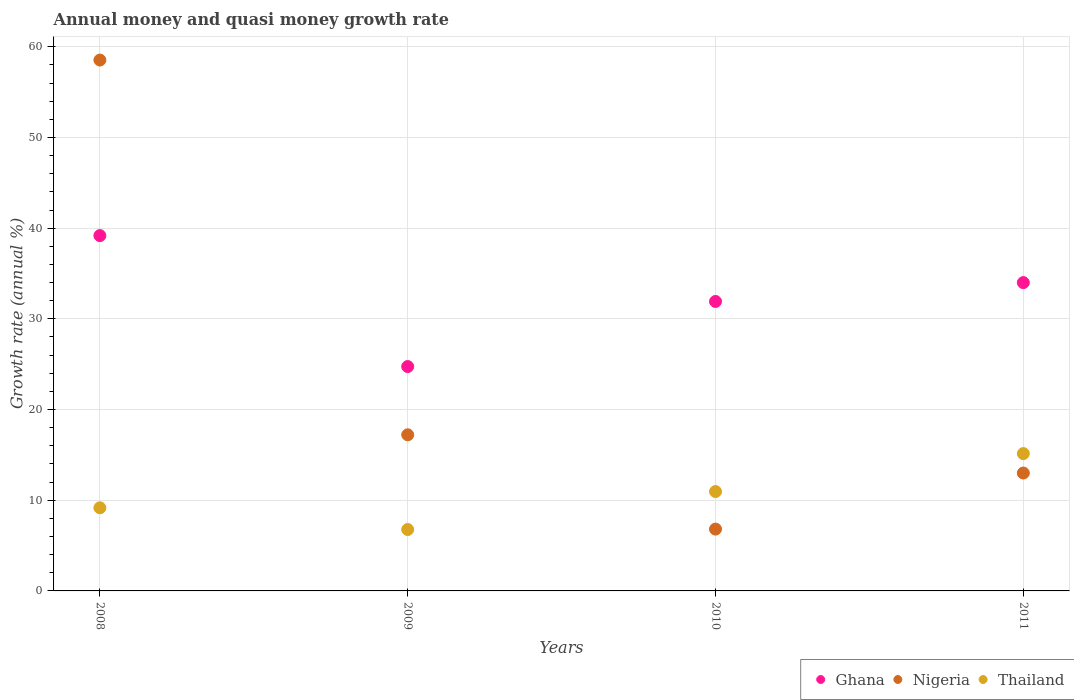How many different coloured dotlines are there?
Your answer should be compact. 3. Is the number of dotlines equal to the number of legend labels?
Keep it short and to the point. Yes. What is the growth rate in Ghana in 2008?
Make the answer very short. 39.18. Across all years, what is the maximum growth rate in Thailand?
Ensure brevity in your answer.  15.14. Across all years, what is the minimum growth rate in Nigeria?
Provide a succinct answer. 6.82. In which year was the growth rate in Thailand maximum?
Offer a very short reply. 2011. What is the total growth rate in Nigeria in the graph?
Make the answer very short. 95.56. What is the difference between the growth rate in Nigeria in 2008 and that in 2010?
Your answer should be compact. 51.72. What is the difference between the growth rate in Nigeria in 2009 and the growth rate in Ghana in 2010?
Offer a very short reply. -14.7. What is the average growth rate in Thailand per year?
Keep it short and to the point. 10.51. In the year 2009, what is the difference between the growth rate in Nigeria and growth rate in Thailand?
Your answer should be compact. 10.44. In how many years, is the growth rate in Thailand greater than 4 %?
Offer a very short reply. 4. What is the ratio of the growth rate in Ghana in 2009 to that in 2010?
Offer a very short reply. 0.78. Is the growth rate in Nigeria in 2009 less than that in 2011?
Ensure brevity in your answer.  No. Is the difference between the growth rate in Nigeria in 2008 and 2011 greater than the difference between the growth rate in Thailand in 2008 and 2011?
Keep it short and to the point. Yes. What is the difference between the highest and the second highest growth rate in Nigeria?
Your answer should be compact. 41.32. What is the difference between the highest and the lowest growth rate in Thailand?
Offer a terse response. 8.37. Is it the case that in every year, the sum of the growth rate in Ghana and growth rate in Thailand  is greater than the growth rate in Nigeria?
Offer a terse response. No. Does the growth rate in Ghana monotonically increase over the years?
Keep it short and to the point. No. What is the difference between two consecutive major ticks on the Y-axis?
Provide a succinct answer. 10. Are the values on the major ticks of Y-axis written in scientific E-notation?
Ensure brevity in your answer.  No. Does the graph contain any zero values?
Make the answer very short. No. Does the graph contain grids?
Provide a succinct answer. Yes. How many legend labels are there?
Your response must be concise. 3. How are the legend labels stacked?
Your response must be concise. Horizontal. What is the title of the graph?
Keep it short and to the point. Annual money and quasi money growth rate. What is the label or title of the Y-axis?
Your answer should be very brief. Growth rate (annual %). What is the Growth rate (annual %) of Ghana in 2008?
Keep it short and to the point. 39.18. What is the Growth rate (annual %) of Nigeria in 2008?
Ensure brevity in your answer.  58.53. What is the Growth rate (annual %) in Thailand in 2008?
Offer a terse response. 9.17. What is the Growth rate (annual %) in Ghana in 2009?
Provide a succinct answer. 24.74. What is the Growth rate (annual %) of Nigeria in 2009?
Offer a very short reply. 17.21. What is the Growth rate (annual %) in Thailand in 2009?
Your answer should be compact. 6.77. What is the Growth rate (annual %) in Ghana in 2010?
Make the answer very short. 31.92. What is the Growth rate (annual %) of Nigeria in 2010?
Offer a terse response. 6.82. What is the Growth rate (annual %) in Thailand in 2010?
Provide a short and direct response. 10.96. What is the Growth rate (annual %) in Ghana in 2011?
Ensure brevity in your answer.  33.99. What is the Growth rate (annual %) of Nigeria in 2011?
Your response must be concise. 13. What is the Growth rate (annual %) of Thailand in 2011?
Your response must be concise. 15.14. Across all years, what is the maximum Growth rate (annual %) of Ghana?
Your response must be concise. 39.18. Across all years, what is the maximum Growth rate (annual %) in Nigeria?
Make the answer very short. 58.53. Across all years, what is the maximum Growth rate (annual %) in Thailand?
Make the answer very short. 15.14. Across all years, what is the minimum Growth rate (annual %) of Ghana?
Your answer should be very brief. 24.74. Across all years, what is the minimum Growth rate (annual %) in Nigeria?
Ensure brevity in your answer.  6.82. Across all years, what is the minimum Growth rate (annual %) of Thailand?
Keep it short and to the point. 6.77. What is the total Growth rate (annual %) of Ghana in the graph?
Ensure brevity in your answer.  129.83. What is the total Growth rate (annual %) of Nigeria in the graph?
Your answer should be compact. 95.56. What is the total Growth rate (annual %) in Thailand in the graph?
Provide a succinct answer. 42.04. What is the difference between the Growth rate (annual %) in Ghana in 2008 and that in 2009?
Your answer should be compact. 14.44. What is the difference between the Growth rate (annual %) of Nigeria in 2008 and that in 2009?
Your answer should be compact. 41.32. What is the difference between the Growth rate (annual %) of Thailand in 2008 and that in 2009?
Provide a succinct answer. 2.4. What is the difference between the Growth rate (annual %) in Ghana in 2008 and that in 2010?
Your answer should be compact. 7.26. What is the difference between the Growth rate (annual %) of Nigeria in 2008 and that in 2010?
Your response must be concise. 51.72. What is the difference between the Growth rate (annual %) of Thailand in 2008 and that in 2010?
Offer a very short reply. -1.79. What is the difference between the Growth rate (annual %) of Ghana in 2008 and that in 2011?
Offer a terse response. 5.18. What is the difference between the Growth rate (annual %) of Nigeria in 2008 and that in 2011?
Your answer should be very brief. 45.54. What is the difference between the Growth rate (annual %) of Thailand in 2008 and that in 2011?
Give a very brief answer. -5.98. What is the difference between the Growth rate (annual %) of Ghana in 2009 and that in 2010?
Give a very brief answer. -7.18. What is the difference between the Growth rate (annual %) of Nigeria in 2009 and that in 2010?
Offer a terse response. 10.4. What is the difference between the Growth rate (annual %) in Thailand in 2009 and that in 2010?
Make the answer very short. -4.19. What is the difference between the Growth rate (annual %) in Ghana in 2009 and that in 2011?
Your response must be concise. -9.26. What is the difference between the Growth rate (annual %) of Nigeria in 2009 and that in 2011?
Give a very brief answer. 4.22. What is the difference between the Growth rate (annual %) in Thailand in 2009 and that in 2011?
Keep it short and to the point. -8.37. What is the difference between the Growth rate (annual %) in Ghana in 2010 and that in 2011?
Offer a very short reply. -2.08. What is the difference between the Growth rate (annual %) in Nigeria in 2010 and that in 2011?
Keep it short and to the point. -6.18. What is the difference between the Growth rate (annual %) in Thailand in 2010 and that in 2011?
Give a very brief answer. -4.18. What is the difference between the Growth rate (annual %) of Ghana in 2008 and the Growth rate (annual %) of Nigeria in 2009?
Your response must be concise. 21.96. What is the difference between the Growth rate (annual %) in Ghana in 2008 and the Growth rate (annual %) in Thailand in 2009?
Offer a terse response. 32.41. What is the difference between the Growth rate (annual %) of Nigeria in 2008 and the Growth rate (annual %) of Thailand in 2009?
Offer a terse response. 51.76. What is the difference between the Growth rate (annual %) in Ghana in 2008 and the Growth rate (annual %) in Nigeria in 2010?
Keep it short and to the point. 32.36. What is the difference between the Growth rate (annual %) of Ghana in 2008 and the Growth rate (annual %) of Thailand in 2010?
Ensure brevity in your answer.  28.22. What is the difference between the Growth rate (annual %) of Nigeria in 2008 and the Growth rate (annual %) of Thailand in 2010?
Make the answer very short. 47.58. What is the difference between the Growth rate (annual %) of Ghana in 2008 and the Growth rate (annual %) of Nigeria in 2011?
Offer a terse response. 26.18. What is the difference between the Growth rate (annual %) in Ghana in 2008 and the Growth rate (annual %) in Thailand in 2011?
Provide a short and direct response. 24.04. What is the difference between the Growth rate (annual %) of Nigeria in 2008 and the Growth rate (annual %) of Thailand in 2011?
Provide a short and direct response. 43.39. What is the difference between the Growth rate (annual %) of Ghana in 2009 and the Growth rate (annual %) of Nigeria in 2010?
Keep it short and to the point. 17.92. What is the difference between the Growth rate (annual %) of Ghana in 2009 and the Growth rate (annual %) of Thailand in 2010?
Your answer should be compact. 13.78. What is the difference between the Growth rate (annual %) in Nigeria in 2009 and the Growth rate (annual %) in Thailand in 2010?
Your response must be concise. 6.26. What is the difference between the Growth rate (annual %) of Ghana in 2009 and the Growth rate (annual %) of Nigeria in 2011?
Your response must be concise. 11.74. What is the difference between the Growth rate (annual %) in Ghana in 2009 and the Growth rate (annual %) in Thailand in 2011?
Make the answer very short. 9.6. What is the difference between the Growth rate (annual %) in Nigeria in 2009 and the Growth rate (annual %) in Thailand in 2011?
Ensure brevity in your answer.  2.07. What is the difference between the Growth rate (annual %) of Ghana in 2010 and the Growth rate (annual %) of Nigeria in 2011?
Make the answer very short. 18.92. What is the difference between the Growth rate (annual %) of Ghana in 2010 and the Growth rate (annual %) of Thailand in 2011?
Your response must be concise. 16.78. What is the difference between the Growth rate (annual %) of Nigeria in 2010 and the Growth rate (annual %) of Thailand in 2011?
Keep it short and to the point. -8.33. What is the average Growth rate (annual %) of Ghana per year?
Keep it short and to the point. 32.46. What is the average Growth rate (annual %) of Nigeria per year?
Offer a terse response. 23.89. What is the average Growth rate (annual %) in Thailand per year?
Provide a short and direct response. 10.51. In the year 2008, what is the difference between the Growth rate (annual %) in Ghana and Growth rate (annual %) in Nigeria?
Ensure brevity in your answer.  -19.36. In the year 2008, what is the difference between the Growth rate (annual %) of Ghana and Growth rate (annual %) of Thailand?
Your response must be concise. 30.01. In the year 2008, what is the difference between the Growth rate (annual %) of Nigeria and Growth rate (annual %) of Thailand?
Give a very brief answer. 49.37. In the year 2009, what is the difference between the Growth rate (annual %) of Ghana and Growth rate (annual %) of Nigeria?
Provide a succinct answer. 7.52. In the year 2009, what is the difference between the Growth rate (annual %) of Ghana and Growth rate (annual %) of Thailand?
Your answer should be compact. 17.97. In the year 2009, what is the difference between the Growth rate (annual %) of Nigeria and Growth rate (annual %) of Thailand?
Your answer should be very brief. 10.44. In the year 2010, what is the difference between the Growth rate (annual %) in Ghana and Growth rate (annual %) in Nigeria?
Offer a terse response. 25.1. In the year 2010, what is the difference between the Growth rate (annual %) of Ghana and Growth rate (annual %) of Thailand?
Give a very brief answer. 20.96. In the year 2010, what is the difference between the Growth rate (annual %) in Nigeria and Growth rate (annual %) in Thailand?
Make the answer very short. -4.14. In the year 2011, what is the difference between the Growth rate (annual %) in Ghana and Growth rate (annual %) in Nigeria?
Your answer should be very brief. 21. In the year 2011, what is the difference between the Growth rate (annual %) in Ghana and Growth rate (annual %) in Thailand?
Give a very brief answer. 18.85. In the year 2011, what is the difference between the Growth rate (annual %) in Nigeria and Growth rate (annual %) in Thailand?
Give a very brief answer. -2.14. What is the ratio of the Growth rate (annual %) in Ghana in 2008 to that in 2009?
Keep it short and to the point. 1.58. What is the ratio of the Growth rate (annual %) of Nigeria in 2008 to that in 2009?
Offer a very short reply. 3.4. What is the ratio of the Growth rate (annual %) of Thailand in 2008 to that in 2009?
Your answer should be compact. 1.35. What is the ratio of the Growth rate (annual %) of Ghana in 2008 to that in 2010?
Offer a very short reply. 1.23. What is the ratio of the Growth rate (annual %) in Nigeria in 2008 to that in 2010?
Provide a succinct answer. 8.59. What is the ratio of the Growth rate (annual %) in Thailand in 2008 to that in 2010?
Provide a succinct answer. 0.84. What is the ratio of the Growth rate (annual %) in Ghana in 2008 to that in 2011?
Provide a short and direct response. 1.15. What is the ratio of the Growth rate (annual %) in Nigeria in 2008 to that in 2011?
Your answer should be compact. 4.5. What is the ratio of the Growth rate (annual %) of Thailand in 2008 to that in 2011?
Provide a succinct answer. 0.61. What is the ratio of the Growth rate (annual %) in Ghana in 2009 to that in 2010?
Offer a very short reply. 0.78. What is the ratio of the Growth rate (annual %) of Nigeria in 2009 to that in 2010?
Your answer should be compact. 2.53. What is the ratio of the Growth rate (annual %) of Thailand in 2009 to that in 2010?
Ensure brevity in your answer.  0.62. What is the ratio of the Growth rate (annual %) in Ghana in 2009 to that in 2011?
Make the answer very short. 0.73. What is the ratio of the Growth rate (annual %) of Nigeria in 2009 to that in 2011?
Provide a short and direct response. 1.32. What is the ratio of the Growth rate (annual %) of Thailand in 2009 to that in 2011?
Offer a very short reply. 0.45. What is the ratio of the Growth rate (annual %) of Ghana in 2010 to that in 2011?
Your answer should be very brief. 0.94. What is the ratio of the Growth rate (annual %) in Nigeria in 2010 to that in 2011?
Your response must be concise. 0.52. What is the ratio of the Growth rate (annual %) in Thailand in 2010 to that in 2011?
Your answer should be very brief. 0.72. What is the difference between the highest and the second highest Growth rate (annual %) in Ghana?
Provide a short and direct response. 5.18. What is the difference between the highest and the second highest Growth rate (annual %) in Nigeria?
Your answer should be compact. 41.32. What is the difference between the highest and the second highest Growth rate (annual %) in Thailand?
Your response must be concise. 4.18. What is the difference between the highest and the lowest Growth rate (annual %) in Ghana?
Ensure brevity in your answer.  14.44. What is the difference between the highest and the lowest Growth rate (annual %) of Nigeria?
Offer a very short reply. 51.72. What is the difference between the highest and the lowest Growth rate (annual %) of Thailand?
Offer a very short reply. 8.37. 